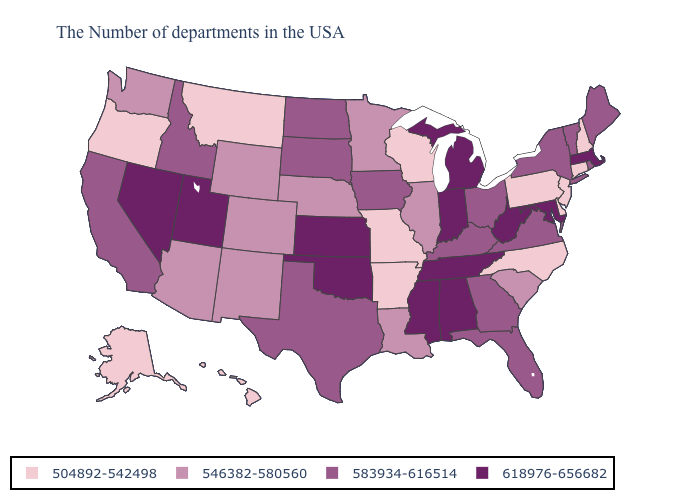Which states have the lowest value in the Northeast?
Give a very brief answer. New Hampshire, Connecticut, New Jersey, Pennsylvania. Name the states that have a value in the range 546382-580560?
Quick response, please. South Carolina, Illinois, Louisiana, Minnesota, Nebraska, Wyoming, Colorado, New Mexico, Arizona, Washington. Among the states that border Arizona , does Colorado have the highest value?
Short answer required. No. Does the map have missing data?
Short answer required. No. Among the states that border South Carolina , which have the lowest value?
Be succinct. North Carolina. Name the states that have a value in the range 583934-616514?
Be succinct. Maine, Rhode Island, Vermont, New York, Virginia, Ohio, Florida, Georgia, Kentucky, Iowa, Texas, South Dakota, North Dakota, Idaho, California. Among the states that border Minnesota , which have the highest value?
Quick response, please. Iowa, South Dakota, North Dakota. Name the states that have a value in the range 618976-656682?
Be succinct. Massachusetts, Maryland, West Virginia, Michigan, Indiana, Alabama, Tennessee, Mississippi, Kansas, Oklahoma, Utah, Nevada. What is the highest value in the Northeast ?
Short answer required. 618976-656682. Among the states that border Georgia , which have the lowest value?
Quick response, please. North Carolina. Name the states that have a value in the range 583934-616514?
Short answer required. Maine, Rhode Island, Vermont, New York, Virginia, Ohio, Florida, Georgia, Kentucky, Iowa, Texas, South Dakota, North Dakota, Idaho, California. Which states have the lowest value in the Northeast?
Give a very brief answer. New Hampshire, Connecticut, New Jersey, Pennsylvania. Among the states that border Connecticut , which have the highest value?
Short answer required. Massachusetts. Name the states that have a value in the range 618976-656682?
Short answer required. Massachusetts, Maryland, West Virginia, Michigan, Indiana, Alabama, Tennessee, Mississippi, Kansas, Oklahoma, Utah, Nevada. What is the value of Colorado?
Short answer required. 546382-580560. 